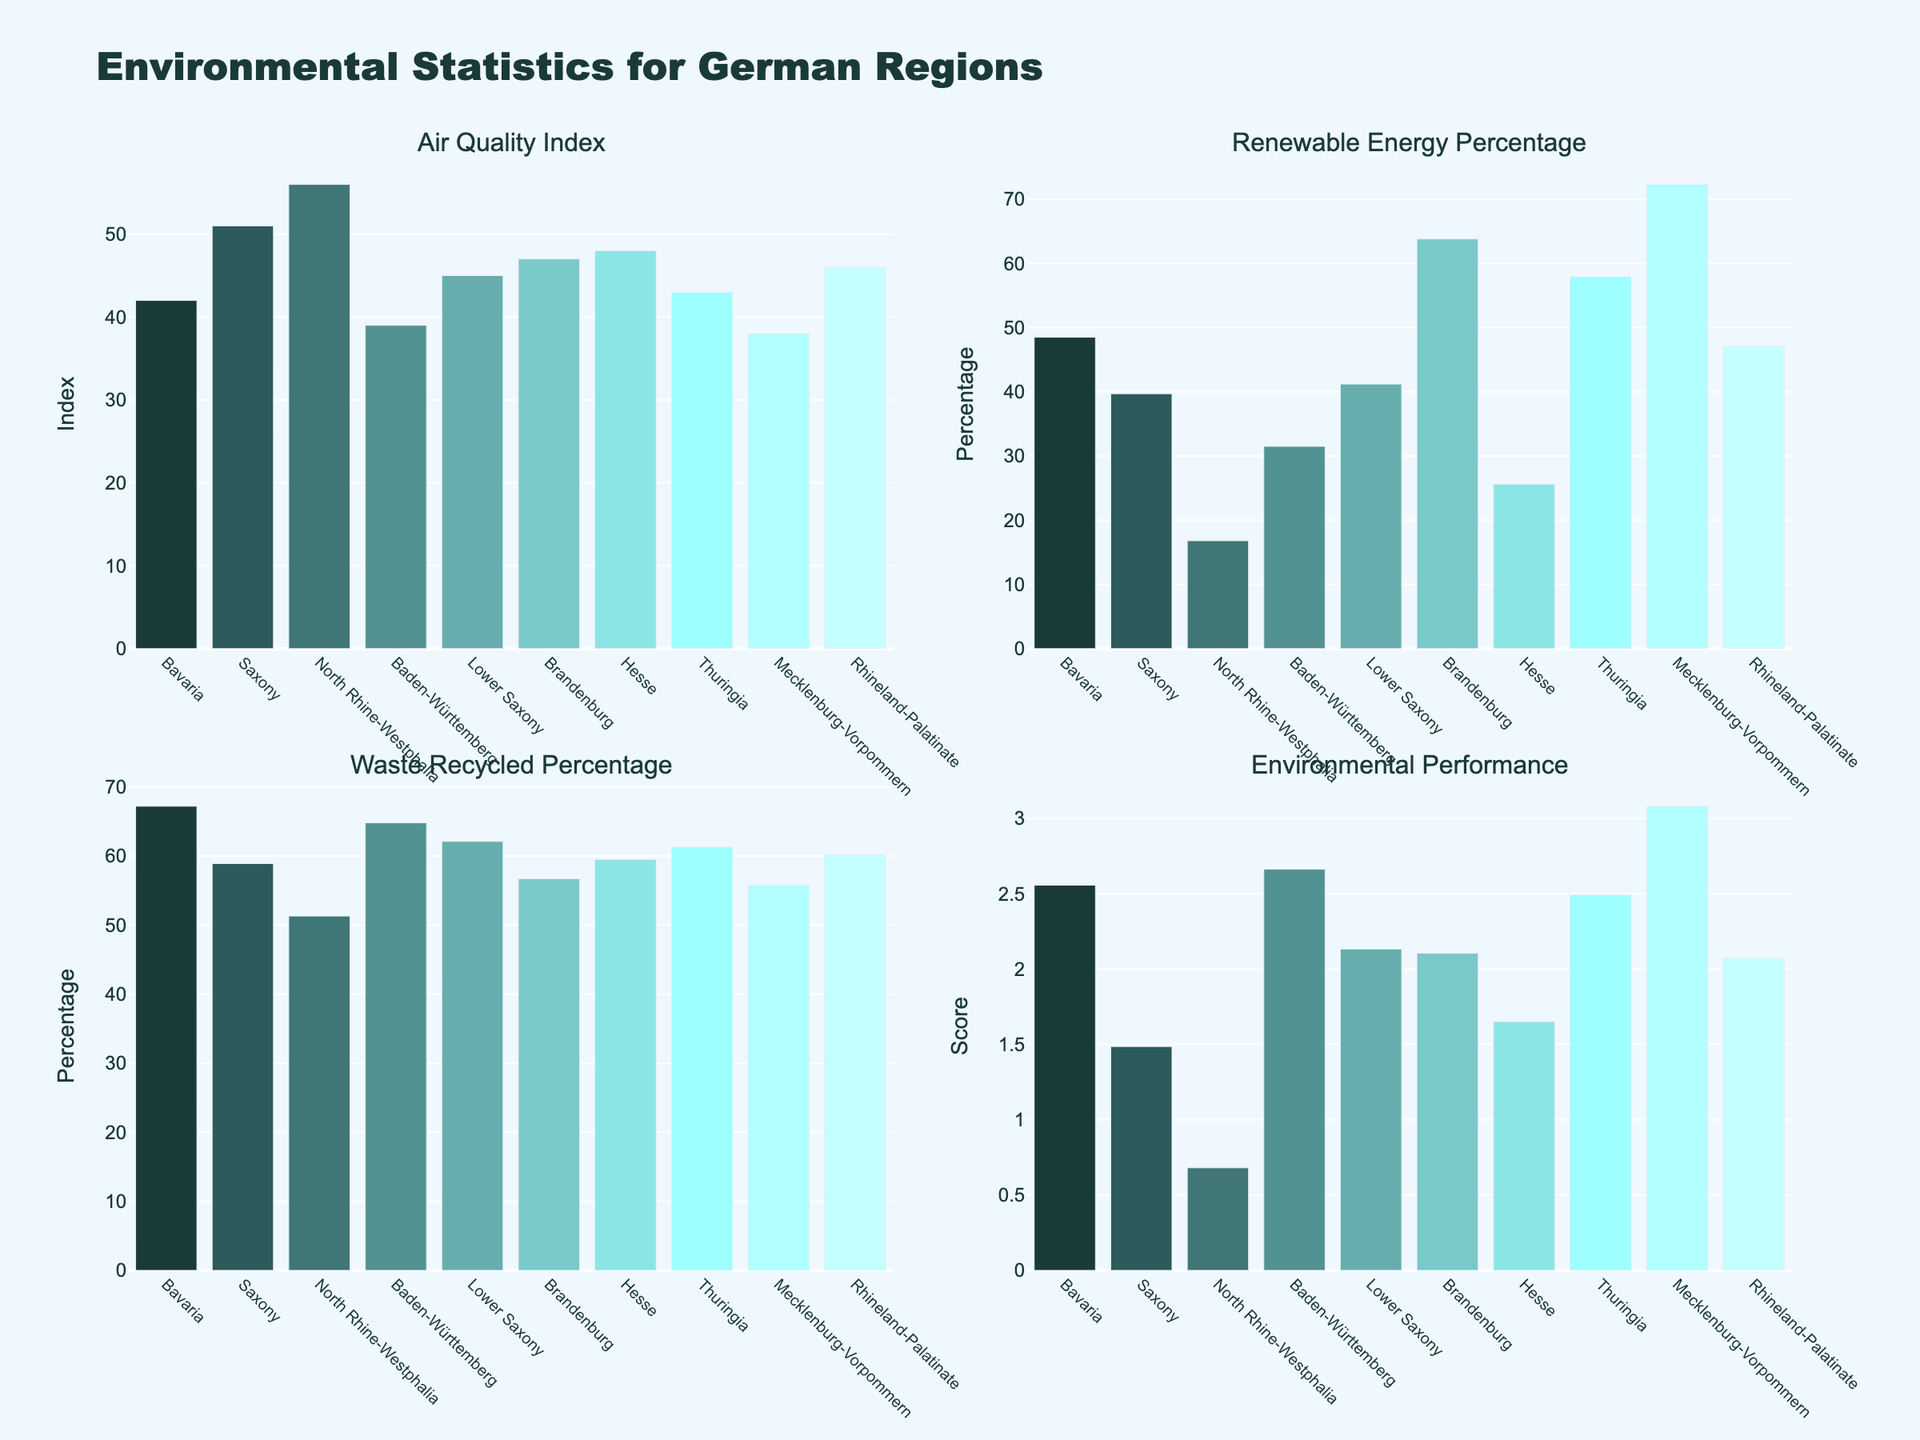What's the title of the figure? The title is located at the top center of the figure. It is 'Citation Network Analysis of EU Court Decisions'.
Answer: Citation Network Analysis of EU Court Decisions Which legal domain has the highest citation count? This can be determined by looking at the bar chart in the top left subplot. The highest bar represents Human Rights.
Answer: Human Rights How many citations did the European Convention on Human Rights receive? The citation count can be found in the pie chart in the top right subplot. The percentage value corresponding to the European Convention on Human Rights slice is stated.
Answer: 87 Which EU court has cited international law the most? The total citations for each court are shown in the bar chart in the bottom left subplot. The highest bar represents the CJEU.
Answer: CJEU What is the trend of the citation count over the years? The scatter plot in the bottom right subplot shows citation counts over different years. The plot demonstrates an overall increasing trend.
Answer: Increasing Compare the citation counts of the Paris Agreement and the Aarhus Convention in 2022. Which one was cited more? From the bar chart in the top left subplot, locate the counts for the Paris Agreement and the Aarhus Convention. The Paris Agreement received 38 citations, whereas the Aarhus Convention received 45 citations.
Answer: Aarhus Convention What was the total citation count in 2021? To find this, sum the citation counts for each entry in the year 2021 as represented in the scatter plot for the year 2021: 38 (Paris Agreement) + 51 (UNCITRAL Model Law) + 33 (UN Convention against Transnational Organized Crime) + 76 (International Covenant on Civil and Political Rights) + 27 (Convention on Biological Diversity).
Answer: 225 How does the citation count for the Rome Statute of the ICC in 2020 compare to the UN Convention against Corruption in 2022? Refer to the bar chart in the top left subplot to find: Rome Statute of the ICC (29 in 2020) and UN Convention against Corruption (36 in 2022). The count for the UN Convention against Corruption is higher.
Answer: UN Convention against Corruption Which international law source has the lowest number of citations, and what is that count? This can be figured by looking at the pie chart in the top right subplot. The smallest slice represents the Convention on Biological Diversity.
Answer: Convention on Biological Diversity, 27 